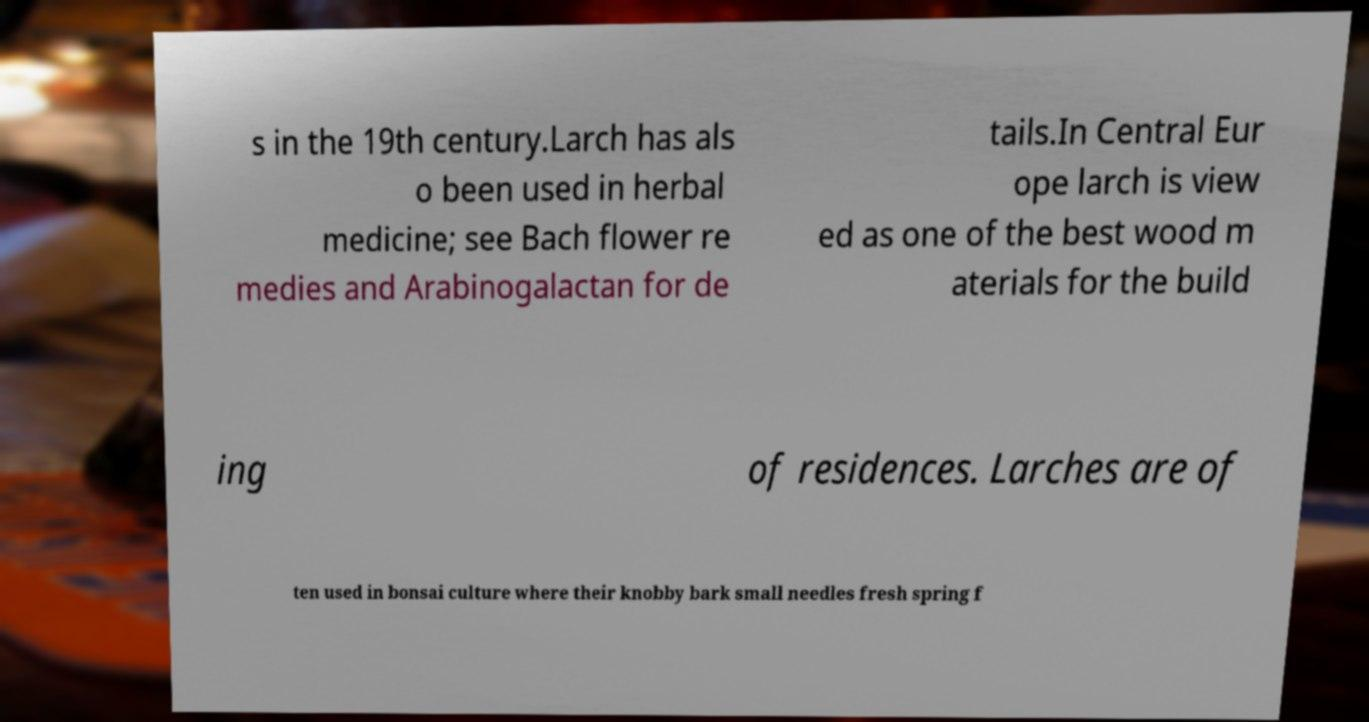Could you extract and type out the text from this image? s in the 19th century.Larch has als o been used in herbal medicine; see Bach flower re medies and Arabinogalactan for de tails.In Central Eur ope larch is view ed as one of the best wood m aterials for the build ing of residences. Larches are of ten used in bonsai culture where their knobby bark small needles fresh spring f 